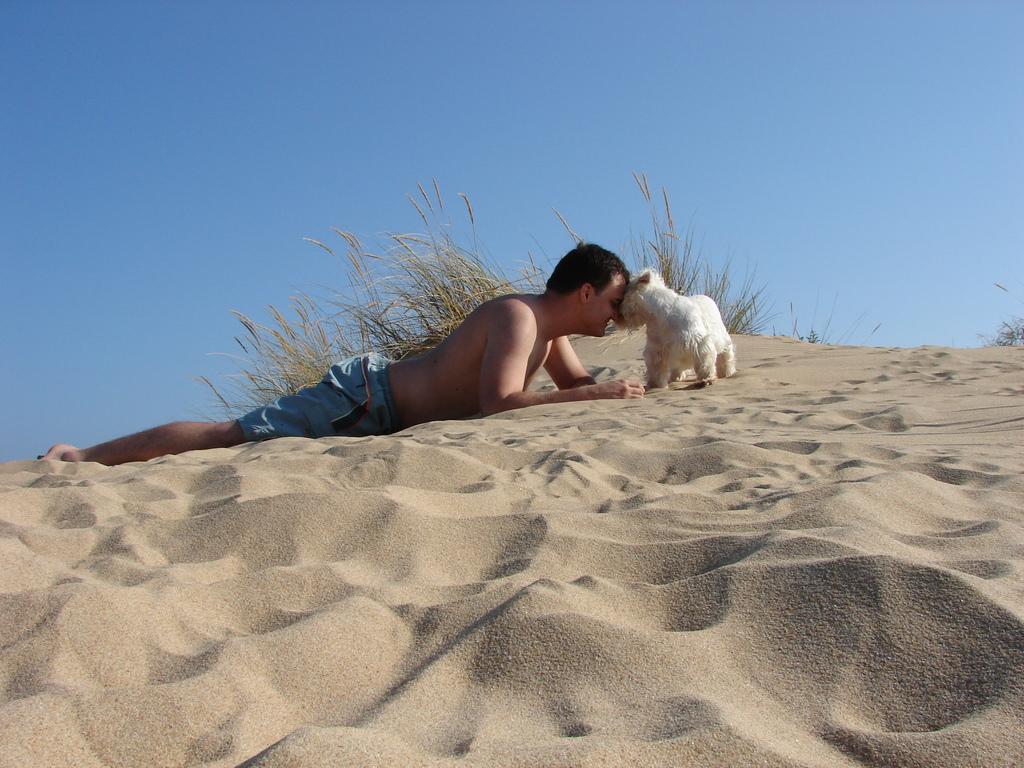Can you describe this image briefly? This picture is taken in a desert where a man is lying on the sand and is playing with a dog. In the background there are trees and a sky. 